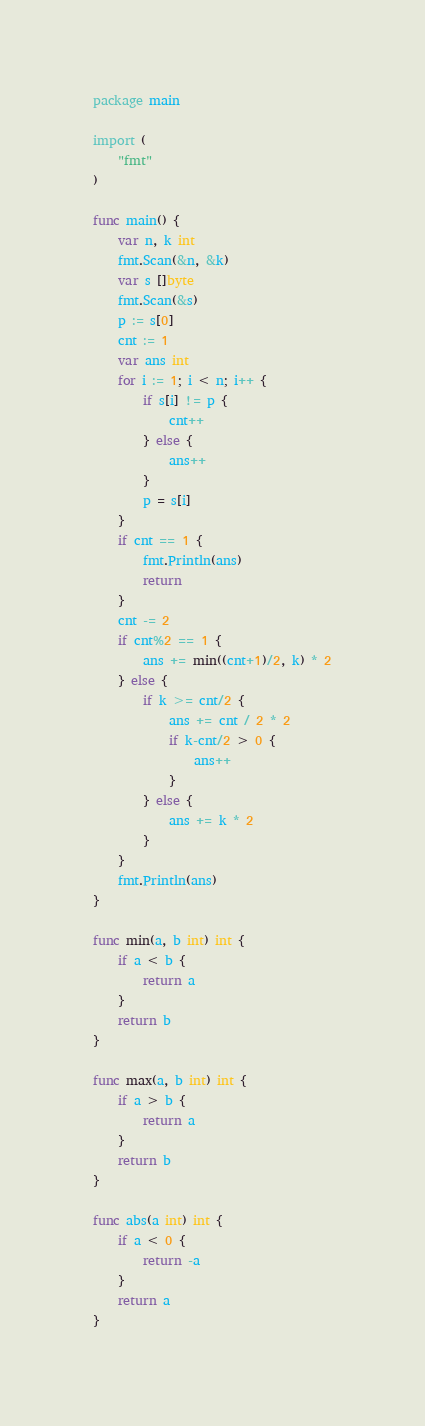Convert code to text. <code><loc_0><loc_0><loc_500><loc_500><_Go_>package main

import (
	"fmt"
)

func main() {
	var n, k int
	fmt.Scan(&n, &k)
	var s []byte
	fmt.Scan(&s)
	p := s[0]
	cnt := 1
	var ans int
	for i := 1; i < n; i++ {
		if s[i] != p {
			cnt++
		} else {
			ans++
		}
		p = s[i]
	}
	if cnt == 1 {
		fmt.Println(ans)
		return
	}
	cnt -= 2
	if cnt%2 == 1 {
		ans += min((cnt+1)/2, k) * 2
	} else {
		if k >= cnt/2 {
			ans += cnt / 2 * 2
			if k-cnt/2 > 0 {
				ans++
			}
		} else {
			ans += k * 2
		}
	}
	fmt.Println(ans)
}

func min(a, b int) int {
	if a < b {
		return a
	}
	return b
}

func max(a, b int) int {
	if a > b {
		return a
	}
	return b
}

func abs(a int) int {
	if a < 0 {
		return -a
	}
	return a
}
</code> 